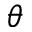Convert formula to latex. <formula><loc_0><loc_0><loc_500><loc_500>\theta</formula> 